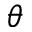Convert formula to latex. <formula><loc_0><loc_0><loc_500><loc_500>\theta</formula> 